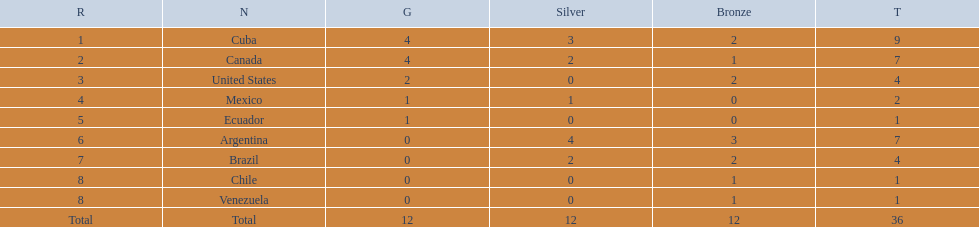Who is ranked #1? Cuba. 